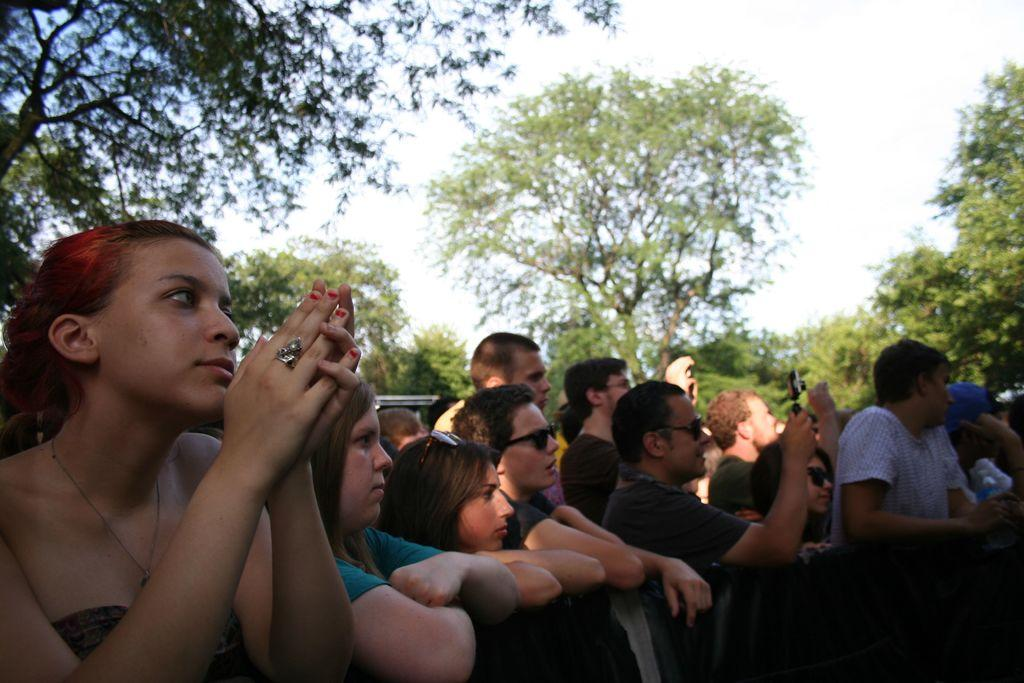What is happening in the center of the image? There are people standing in the center of the image. What can be seen in the background of the image? The sky, clouds, and trees are visible in the background of the image. What type of furniture is being used to measure the distance between the trees in the image? There is no furniture present in the image, and no measurement of distance between trees is depicted. 